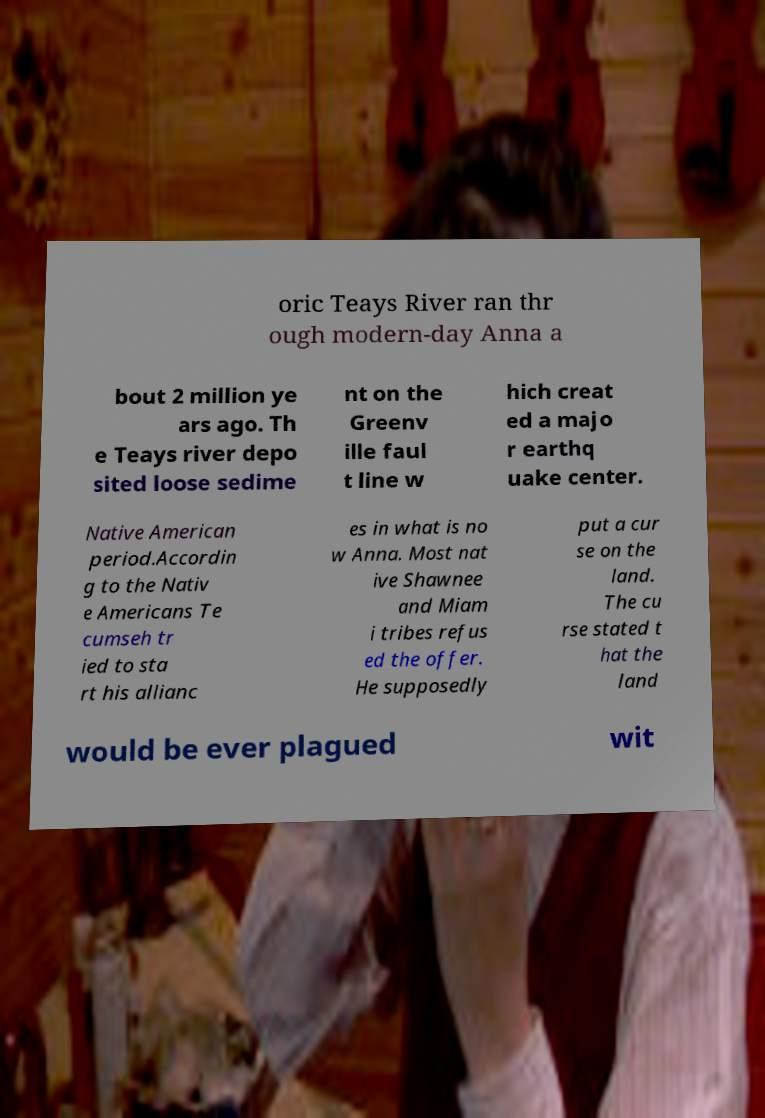There's text embedded in this image that I need extracted. Can you transcribe it verbatim? oric Teays River ran thr ough modern-day Anna a bout 2 million ye ars ago. Th e Teays river depo sited loose sedime nt on the Greenv ille faul t line w hich creat ed a majo r earthq uake center. Native American period.Accordin g to the Nativ e Americans Te cumseh tr ied to sta rt his allianc es in what is no w Anna. Most nat ive Shawnee and Miam i tribes refus ed the offer. He supposedly put a cur se on the land. The cu rse stated t hat the land would be ever plagued wit 